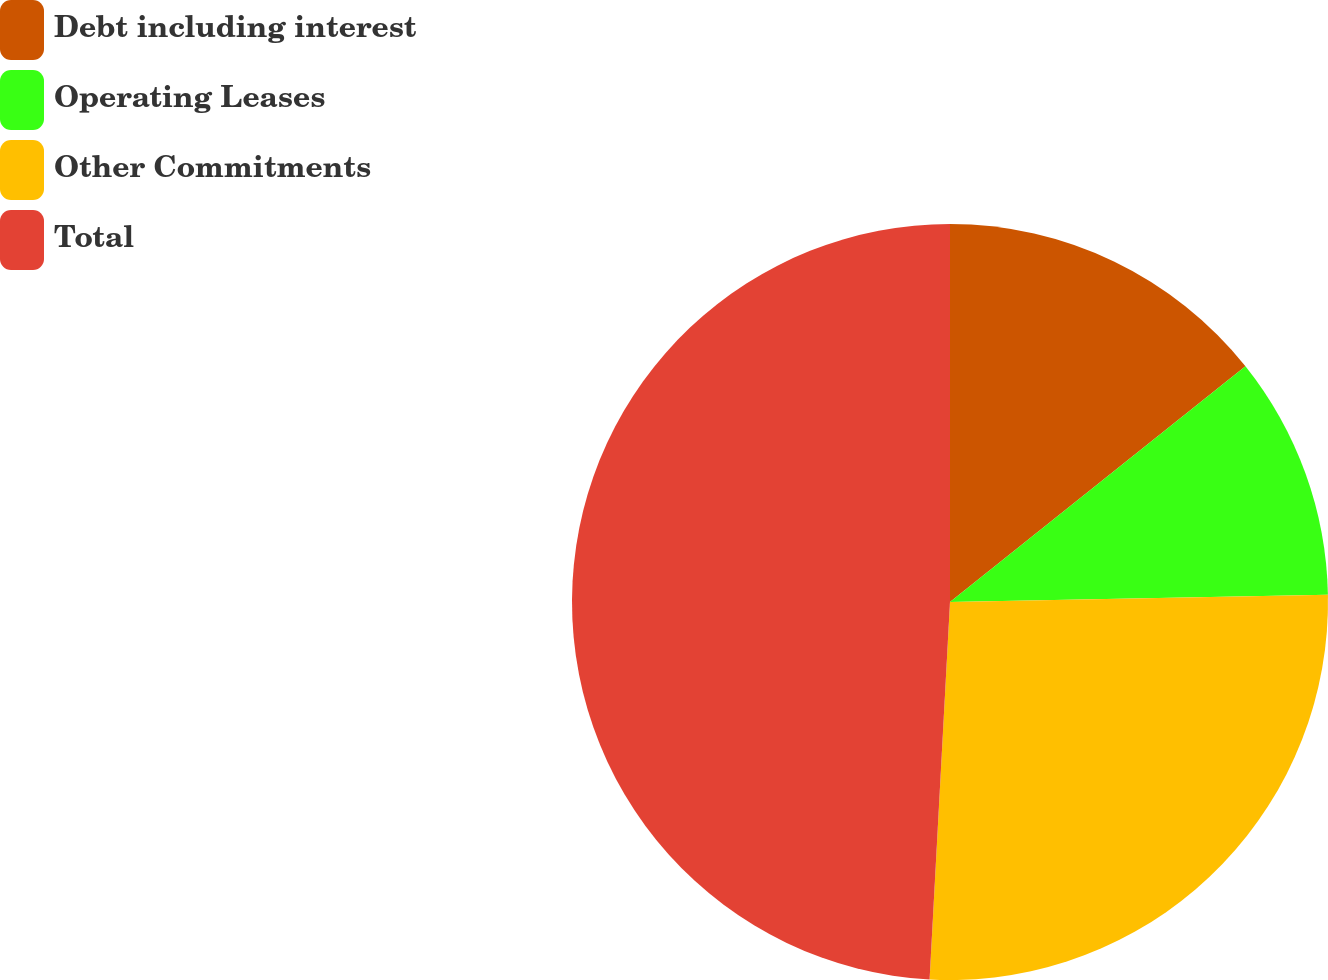<chart> <loc_0><loc_0><loc_500><loc_500><pie_chart><fcel>Debt including interest<fcel>Operating Leases<fcel>Other Commitments<fcel>Total<nl><fcel>14.28%<fcel>10.41%<fcel>26.17%<fcel>49.14%<nl></chart> 